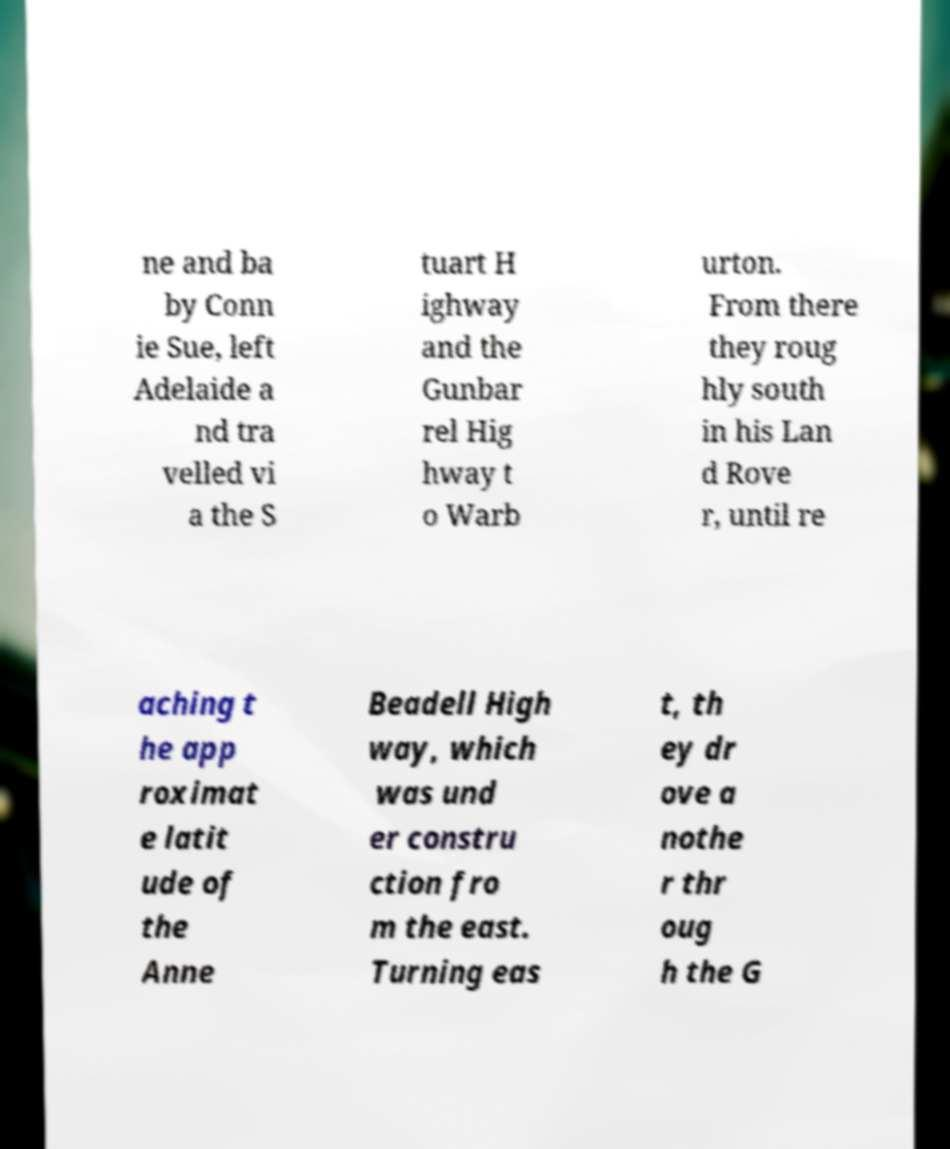I need the written content from this picture converted into text. Can you do that? ne and ba by Conn ie Sue, left Adelaide a nd tra velled vi a the S tuart H ighway and the Gunbar rel Hig hway t o Warb urton. From there they roug hly south in his Lan d Rove r, until re aching t he app roximat e latit ude of the Anne Beadell High way, which was und er constru ction fro m the east. Turning eas t, th ey dr ove a nothe r thr oug h the G 